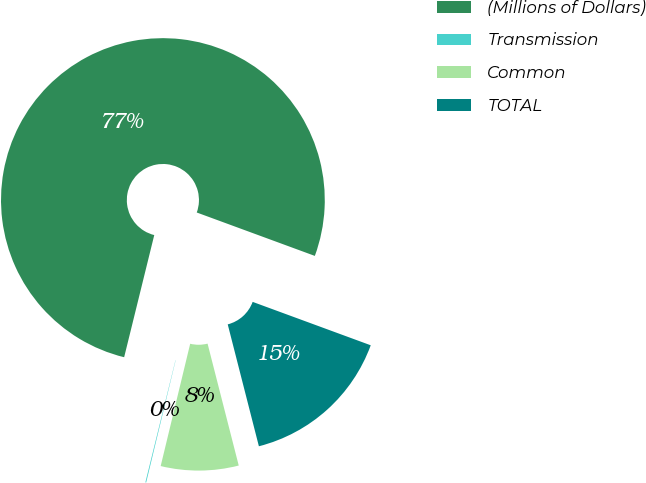<chart> <loc_0><loc_0><loc_500><loc_500><pie_chart><fcel>(Millions of Dollars)<fcel>Transmission<fcel>Common<fcel>TOTAL<nl><fcel>76.76%<fcel>0.08%<fcel>7.75%<fcel>15.41%<nl></chart> 